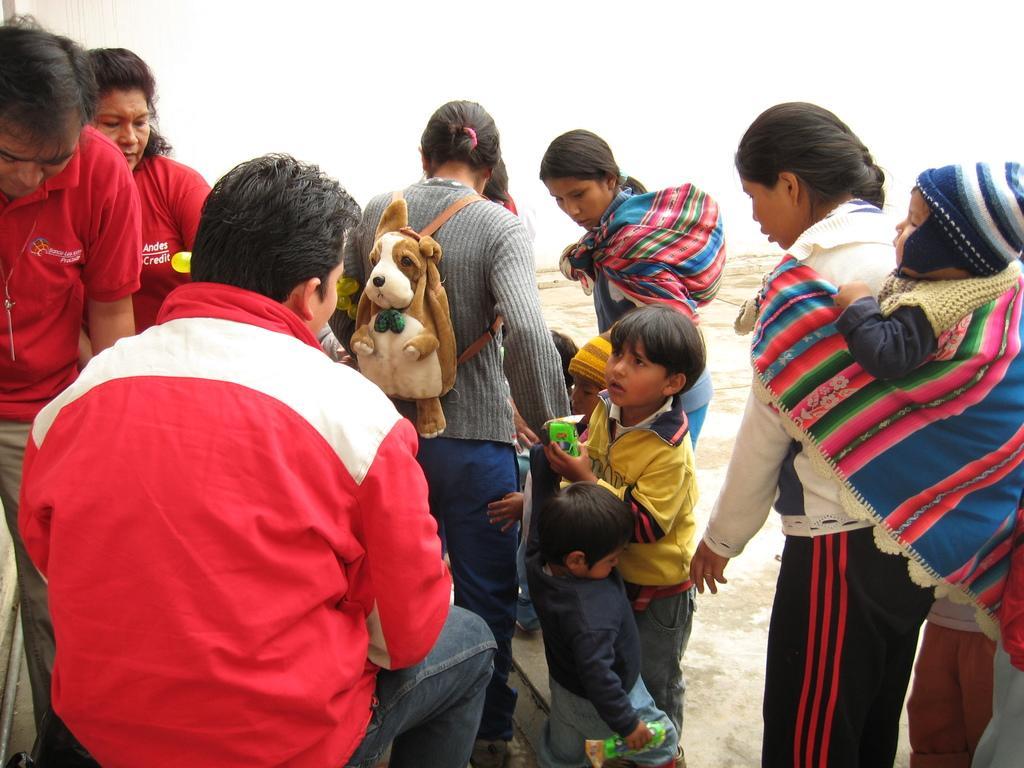In one or two sentences, can you explain what this image depicts? In this image there are men, women and kids, in the center of the image there is a woman wearing a bag. 